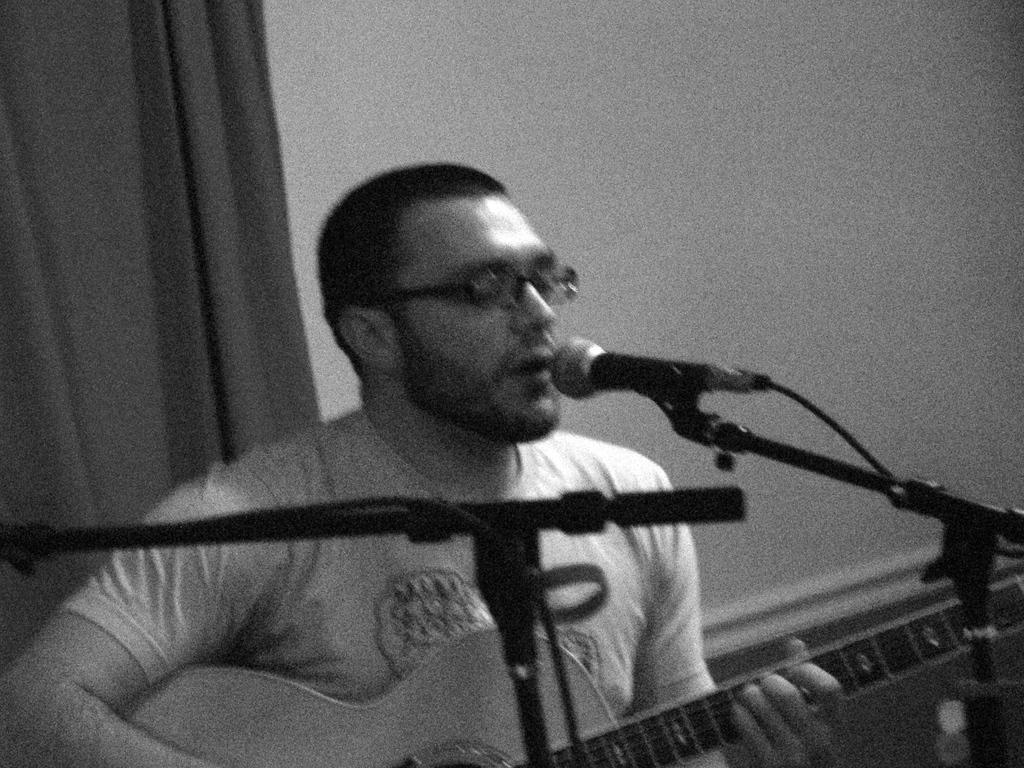How would you summarize this image in a sentence or two? in this picture there was a person singing song in the microphone holding a guitar. 